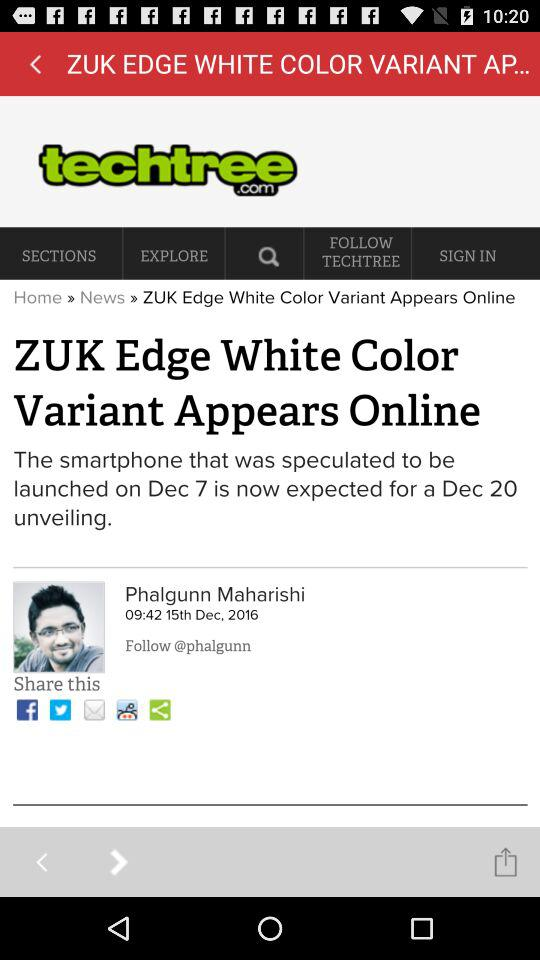Who is the author of the article? The author of the article is Phalgunn Maharishi. 